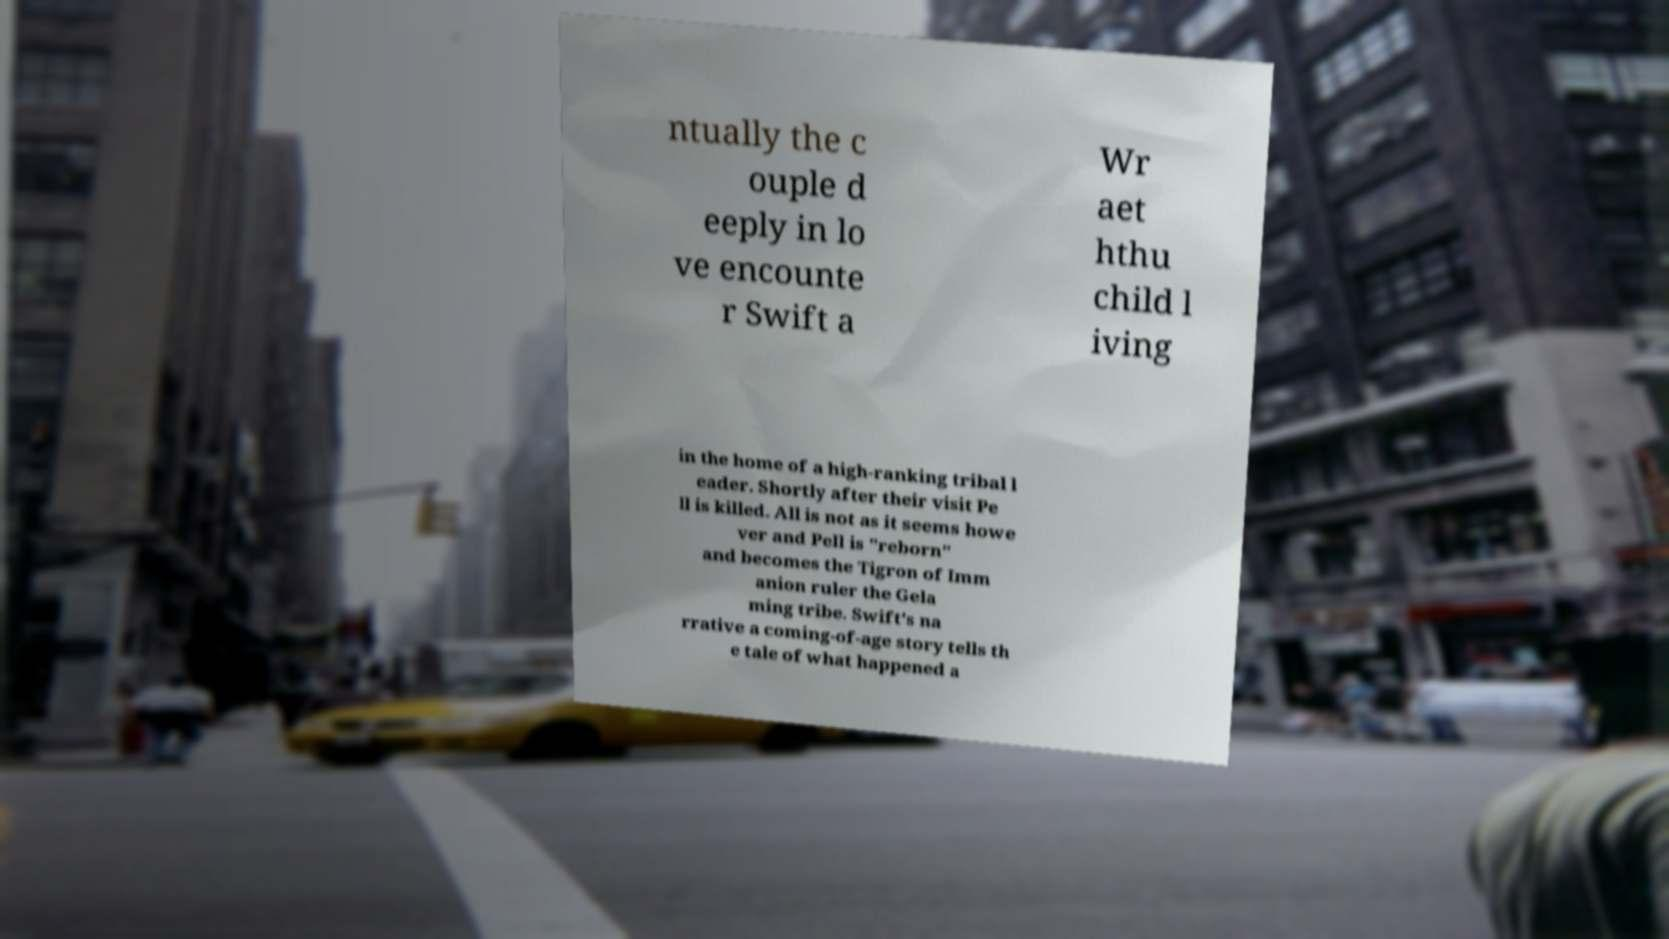Can you accurately transcribe the text from the provided image for me? ntually the c ouple d eeply in lo ve encounte r Swift a Wr aet hthu child l iving in the home of a high-ranking tribal l eader. Shortly after their visit Pe ll is killed. All is not as it seems howe ver and Pell is "reborn" and becomes the Tigron of Imm anion ruler the Gela ming tribe. Swift's na rrative a coming-of-age story tells th e tale of what happened a 